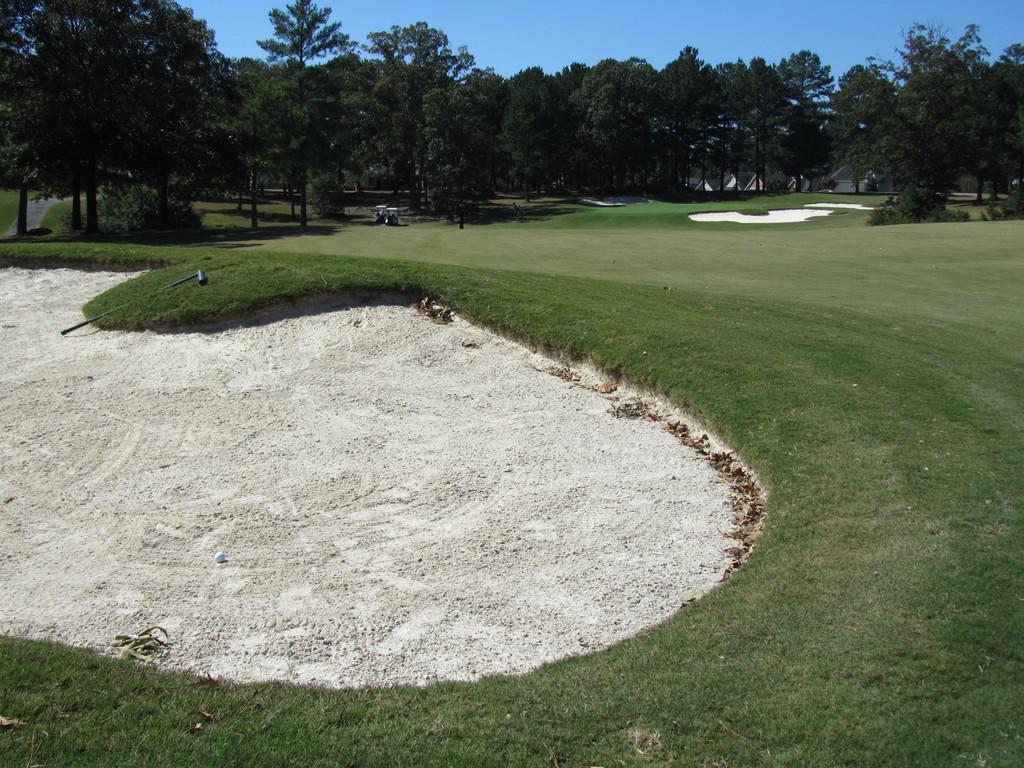Could you give a brief overview of what you see in this image? This image is taken outdoors. At the top of the image there is the sky. In the background there are many trees and plants on the ground. At the bottom of the image there is a ground with grass on it. 